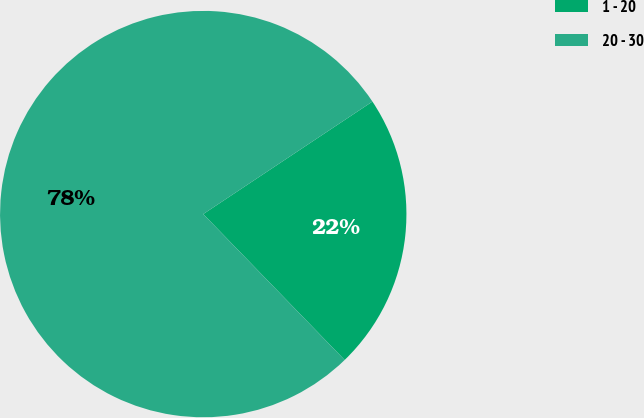Convert chart. <chart><loc_0><loc_0><loc_500><loc_500><pie_chart><fcel>1 - 20<fcel>20 - 30<nl><fcel>22.09%<fcel>77.91%<nl></chart> 